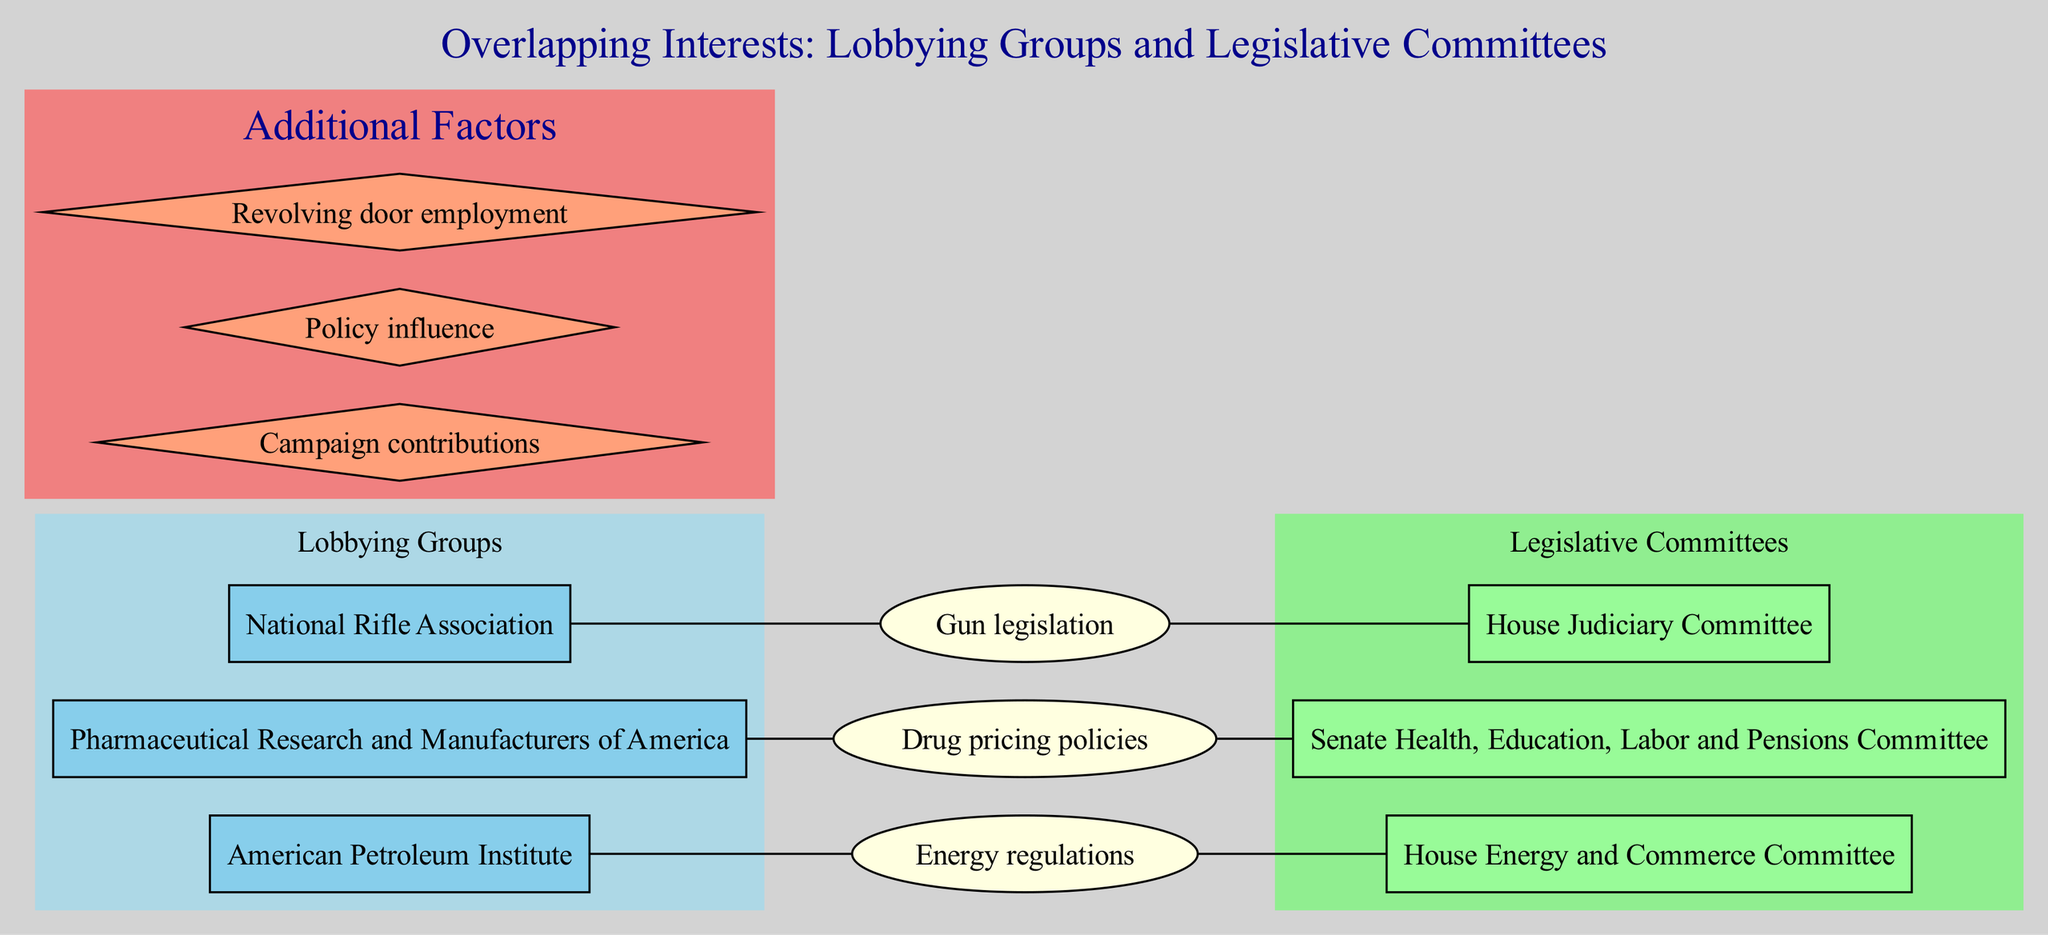What are the names of the lobbying groups depicted in the diagram? The diagram lists three lobbying groups: National Rifle Association, Pharmaceutical Research and Manufacturers of America, and American Petroleum Institute.
Answer: National Rifle Association, Pharmaceutical Research and Manufacturers of America, American Petroleum Institute How many legislative committees are shown in the diagram? The diagram identifies three legislative committees: House Judiciary Committee, Senate Health, Education, Labor and Pensions Committee, and House Energy and Commerce Committee. Counting these gives the total of three.
Answer: 3 What is one policy issue shared by the National Rifle Association? The National Rifle Association shares interests with Gun legislation, which connects it to the House Judiciary Committee.
Answer: Gun legislation Which lobbying group is connected to energy regulations? The American Petroleum Institute is the lobbying group that connects with Energy regulations in the diagram.
Answer: American Petroleum Institute How many overlapping interests are depicted in the diagram? The diagram shows three overlapping interests: Gun legislation, Drug pricing policies, and Energy regulations. Therefore, the answer is three.
Answer: 3 What does the term "revolving door employment" refer to in this context? Revolving door employment refers to the movement of individuals between lobbying roles and legislative positions, indicating potential conflicts of interest and influencing policy decisions in favor of a specific interest.
Answer: Movement between lobbying and legislative positions Which legislative committee is associated with drug pricing policies? The Senate Health, Education, Labor and Pensions Committee is the legislative committee that connects with Drug pricing policies in the diagram.
Answer: Senate Health, Education, Labor and Pensions Committee Identify one of the additional factors noted in the diagram. The diagram lists three additional factors, one of which is campaign contributions as a significant aspect influencing the interactions between lobbying groups and legislative committees.
Answer: Campaign contributions What type of edge connects the House Judiciary Committee and Gun legislation? The edge between them indicates the relationship that Gun legislation is an interest of the National Rifle Association which also pertains to the House Judiciary Committee.
Answer: Edge (relationship) 